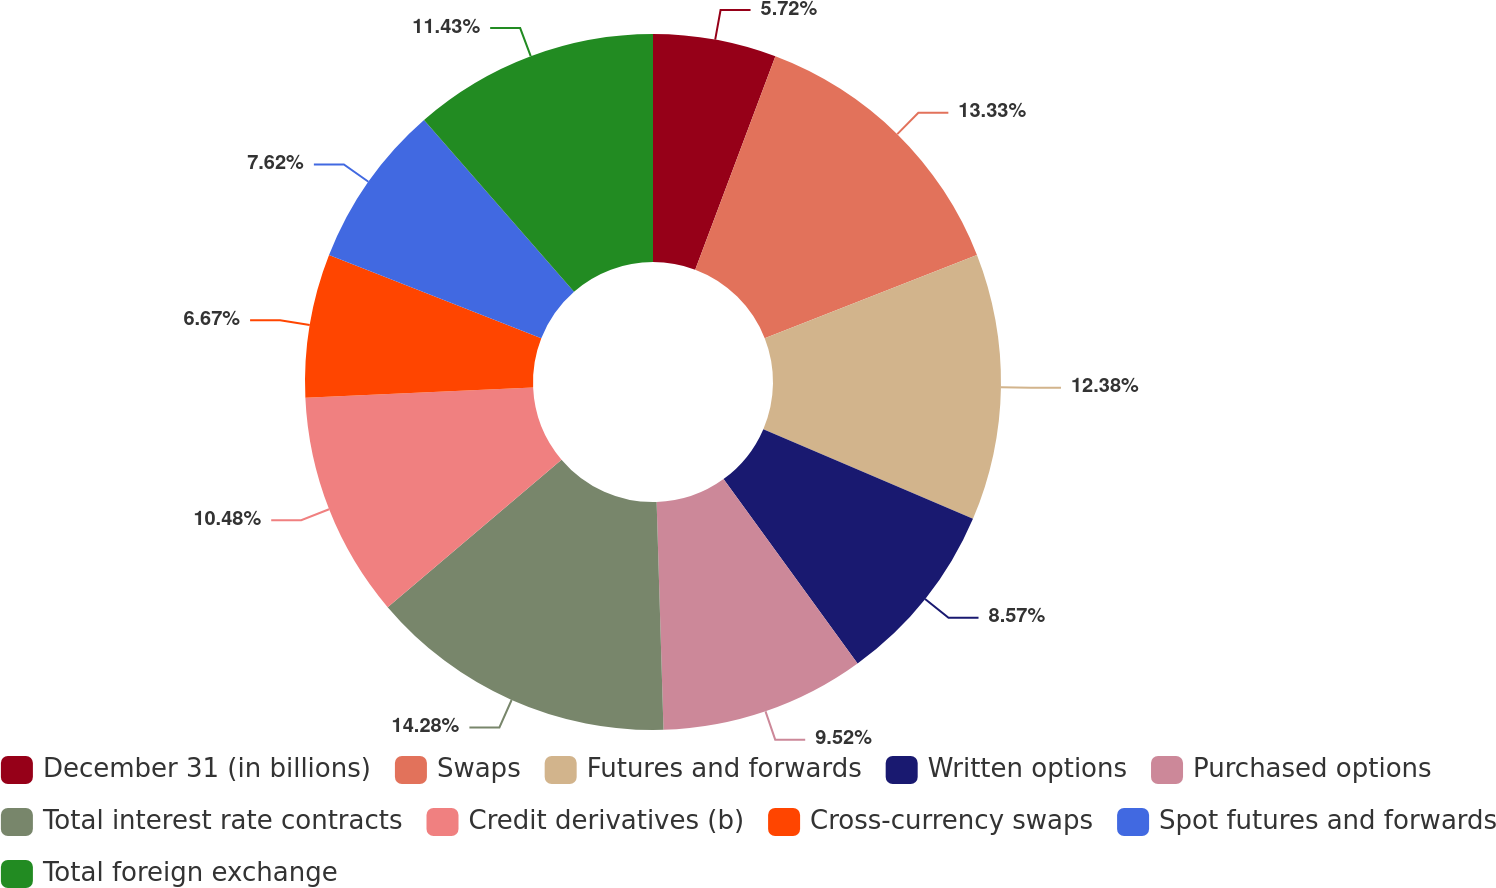Convert chart to OTSL. <chart><loc_0><loc_0><loc_500><loc_500><pie_chart><fcel>December 31 (in billions)<fcel>Swaps<fcel>Futures and forwards<fcel>Written options<fcel>Purchased options<fcel>Total interest rate contracts<fcel>Credit derivatives (b)<fcel>Cross-currency swaps<fcel>Spot futures and forwards<fcel>Total foreign exchange<nl><fcel>5.72%<fcel>13.33%<fcel>12.38%<fcel>8.57%<fcel>9.52%<fcel>14.28%<fcel>10.48%<fcel>6.67%<fcel>7.62%<fcel>11.43%<nl></chart> 